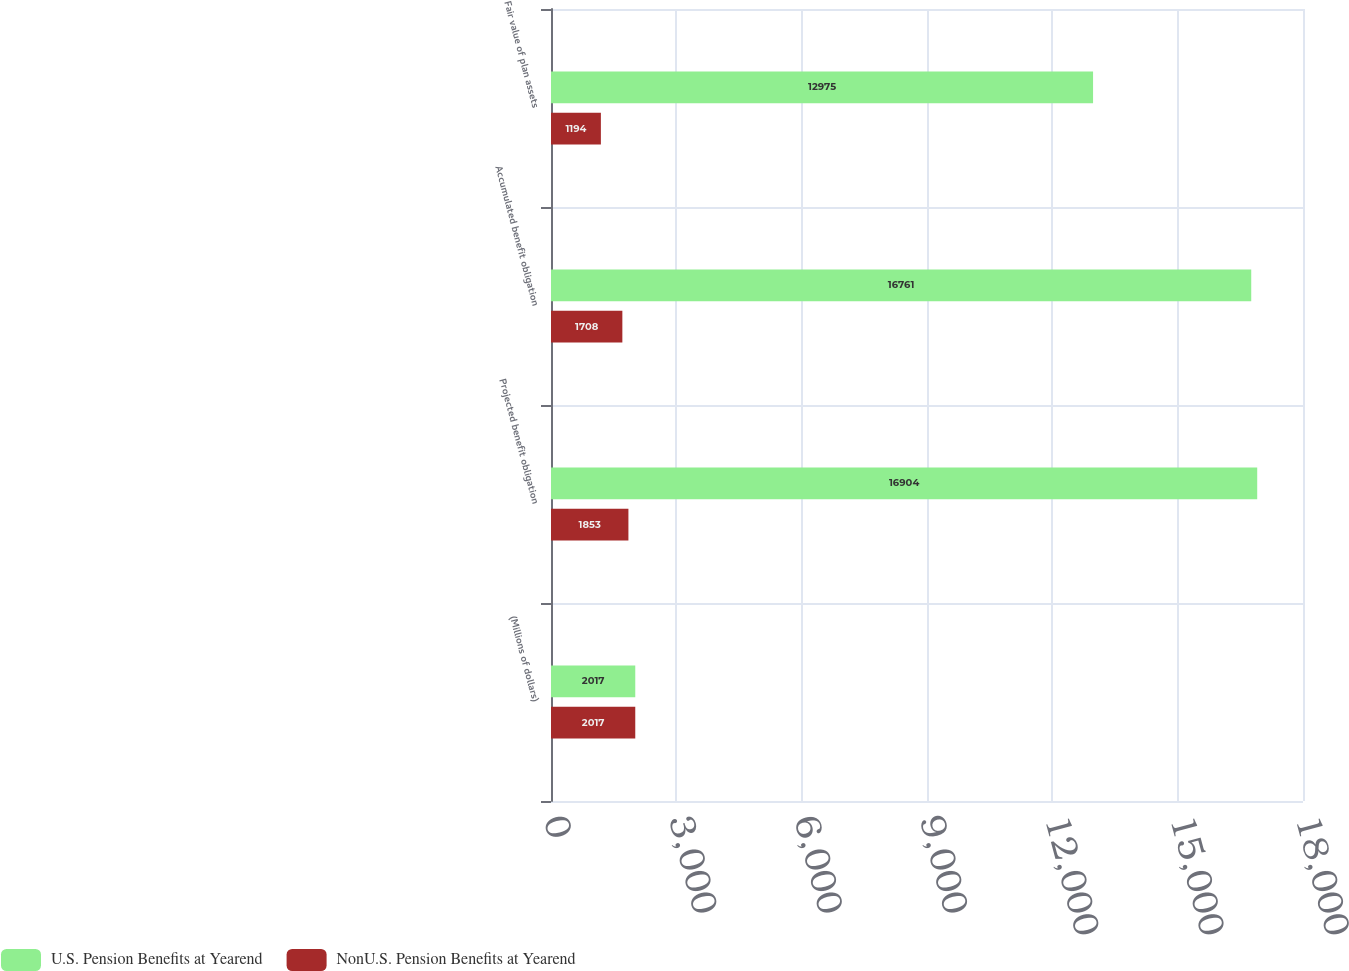Convert chart to OTSL. <chart><loc_0><loc_0><loc_500><loc_500><stacked_bar_chart><ecel><fcel>(Millions of dollars)<fcel>Projected benefit obligation<fcel>Accumulated benefit obligation<fcel>Fair value of plan assets<nl><fcel>U.S. Pension Benefits at Yearend<fcel>2017<fcel>16904<fcel>16761<fcel>12975<nl><fcel>NonU.S. Pension Benefits at Yearend<fcel>2017<fcel>1853<fcel>1708<fcel>1194<nl></chart> 